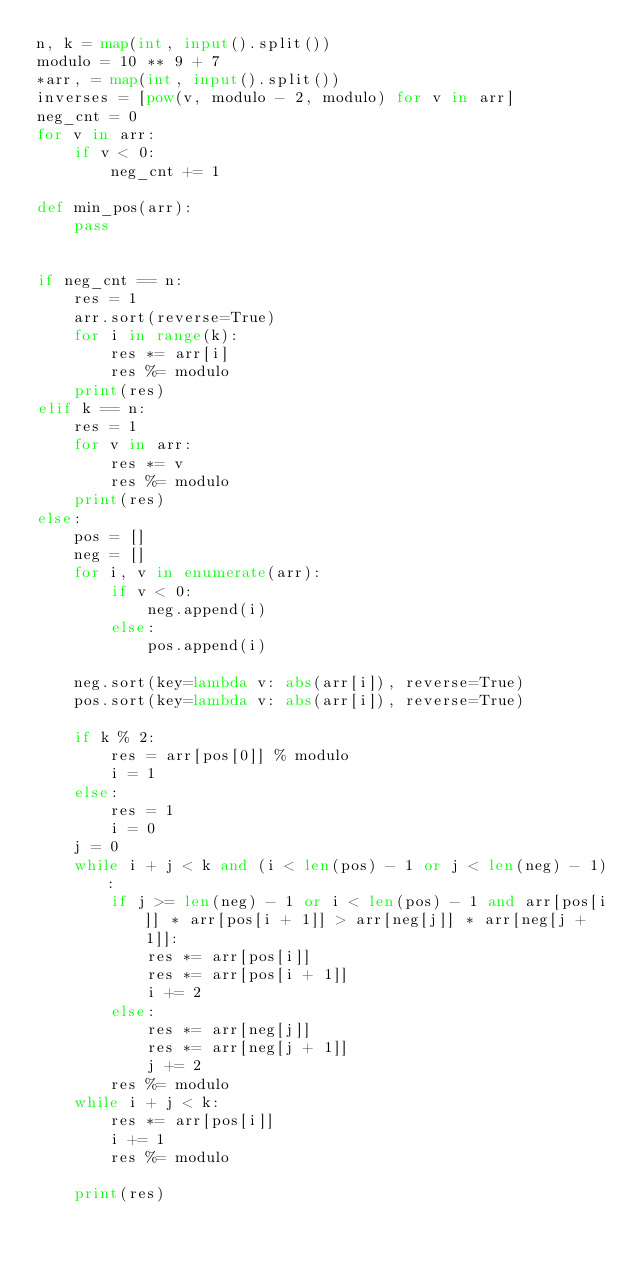Convert code to text. <code><loc_0><loc_0><loc_500><loc_500><_Python_>n, k = map(int, input().split())
modulo = 10 ** 9 + 7
*arr, = map(int, input().split())
inverses = [pow(v, modulo - 2, modulo) for v in arr]
neg_cnt = 0
for v in arr:
    if v < 0:
        neg_cnt += 1

def min_pos(arr):
    pass


if neg_cnt == n:
    res = 1
    arr.sort(reverse=True)
    for i in range(k):
        res *= arr[i]
        res %= modulo
    print(res)
elif k == n:
    res = 1
    for v in arr:
        res *= v
        res %= modulo
    print(res)
else:
    pos = []
    neg = []
    for i, v in enumerate(arr):
        if v < 0:
            neg.append(i)
        else:
            pos.append(i)

    neg.sort(key=lambda v: abs(arr[i]), reverse=True)
    pos.sort(key=lambda v: abs(arr[i]), reverse=True)

    if k % 2:
        res = arr[pos[0]] % modulo
        i = 1
    else:
        res = 1
        i = 0
    j = 0
    while i + j < k and (i < len(pos) - 1 or j < len(neg) - 1):
        if j >= len(neg) - 1 or i < len(pos) - 1 and arr[pos[i]] * arr[pos[i + 1]] > arr[neg[j]] * arr[neg[j + 1]]:
            res *= arr[pos[i]]
            res *= arr[pos[i + 1]]
            i += 2
        else:
            res *= arr[neg[j]]
            res *= arr[neg[j + 1]]
            j += 2
        res %= modulo
    while i + j < k:
        res *= arr[pos[i]]
        i += 1
        res %= modulo

    print(res)


</code> 